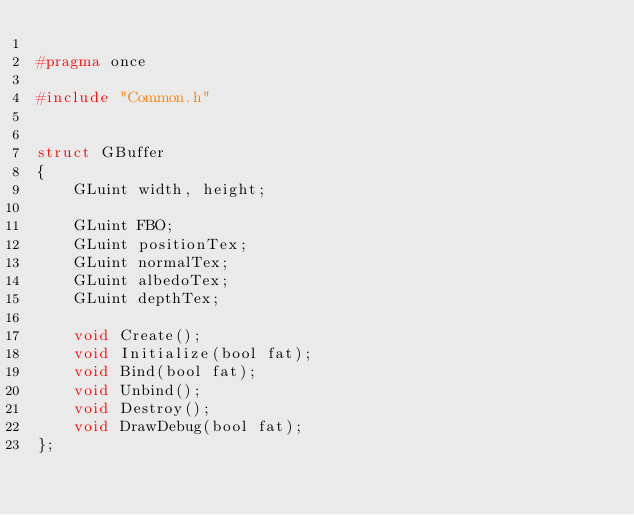Convert code to text. <code><loc_0><loc_0><loc_500><loc_500><_C_>
#pragma once

#include "Common.h"


struct GBuffer
{
	GLuint width, height;

	GLuint FBO;
	GLuint positionTex;
	GLuint normalTex;
	GLuint albedoTex;
	GLuint depthTex;

	void Create();
	void Initialize(bool fat);
	void Bind(bool fat);
	void Unbind();
	void Destroy();
	void DrawDebug(bool fat);
};
</code> 